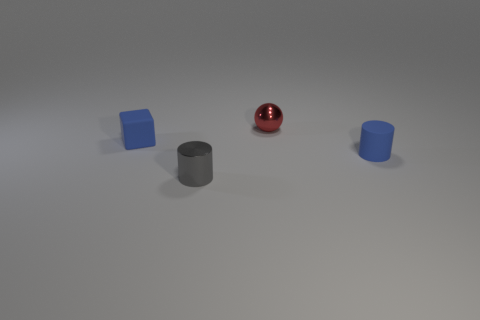Add 1 small blue metallic cubes. How many objects exist? 5 Subtract all spheres. How many objects are left? 3 Subtract all large cyan rubber cylinders. Subtract all spheres. How many objects are left? 3 Add 2 tiny gray metallic cylinders. How many tiny gray metallic cylinders are left? 3 Add 2 big yellow cylinders. How many big yellow cylinders exist? 2 Subtract 0 yellow cylinders. How many objects are left? 4 